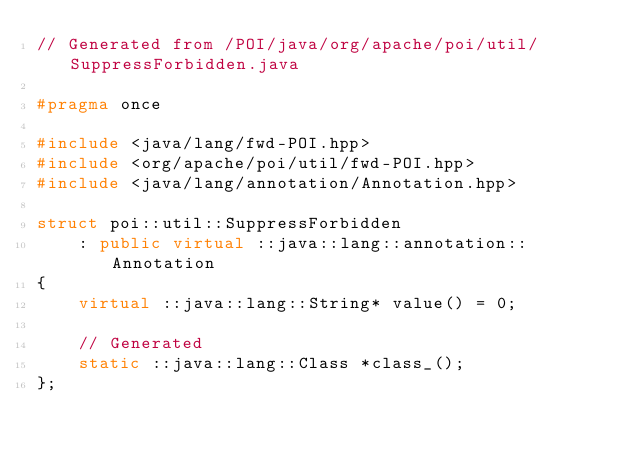Convert code to text. <code><loc_0><loc_0><loc_500><loc_500><_C++_>// Generated from /POI/java/org/apache/poi/util/SuppressForbidden.java

#pragma once

#include <java/lang/fwd-POI.hpp>
#include <org/apache/poi/util/fwd-POI.hpp>
#include <java/lang/annotation/Annotation.hpp>

struct poi::util::SuppressForbidden
    : public virtual ::java::lang::annotation::Annotation
{
    virtual ::java::lang::String* value() = 0;

    // Generated
    static ::java::lang::Class *class_();
};
</code> 